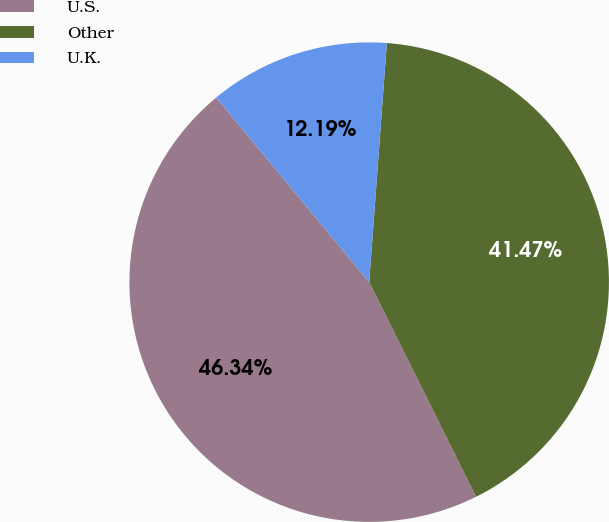Convert chart to OTSL. <chart><loc_0><loc_0><loc_500><loc_500><pie_chart><fcel>U.S.<fcel>Other<fcel>U.K.<nl><fcel>46.34%<fcel>41.47%<fcel>12.19%<nl></chart> 